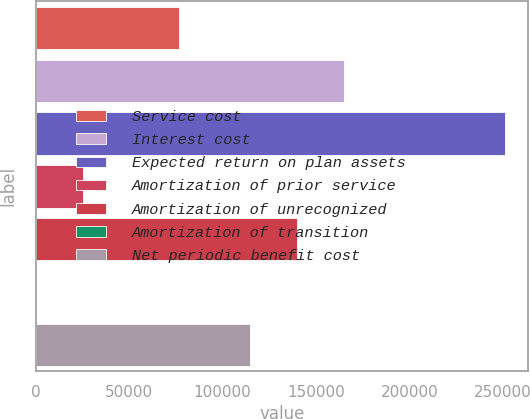<chart> <loc_0><loc_0><loc_500><loc_500><bar_chart><fcel>Service cost<fcel>Interest cost<fcel>Expected return on plan assets<fcel>Amortization of prior service<fcel>Amortization of unrecognized<fcel>Amortization of transition<fcel>Net periodic benefit cost<nl><fcel>76647<fcel>164824<fcel>251072<fcel>25123.4<fcel>139718<fcel>18<fcel>114613<nl></chart> 